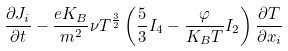Convert formula to latex. <formula><loc_0><loc_0><loc_500><loc_500>\frac { \partial J _ { i } } { \partial t } - \frac { e K _ { B } } { m ^ { 2 } } \nu T ^ { \frac { 3 } { 2 } } \left ( \frac { 5 } { 3 } I _ { 4 } - \frac { \varphi } { K _ { B } T } I _ { 2 } \right ) \frac { \partial T } { \partial x _ { i } }</formula> 